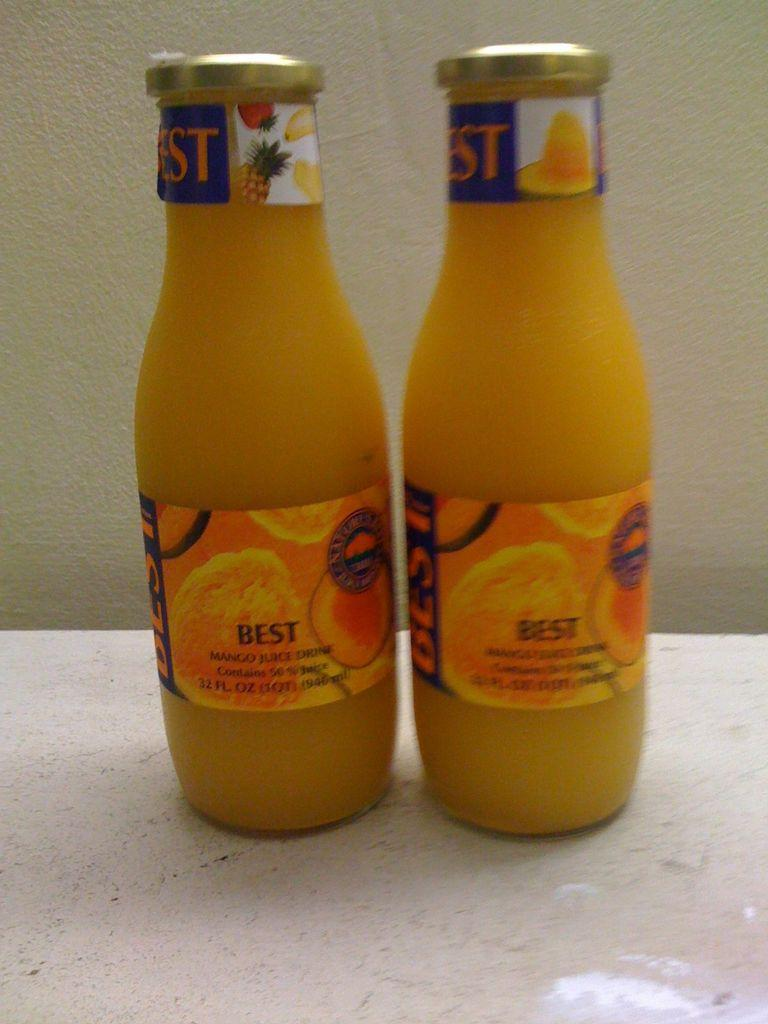<image>
Render a clear and concise summary of the photo. Two glass bottles of a fruit juice called Best. 